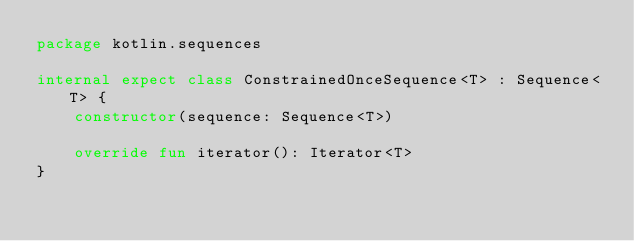<code> <loc_0><loc_0><loc_500><loc_500><_Kotlin_>package kotlin.sequences

internal expect class ConstrainedOnceSequence<T> : Sequence<T> {
    constructor(sequence: Sequence<T>)

    override fun iterator(): Iterator<T>
}
</code> 